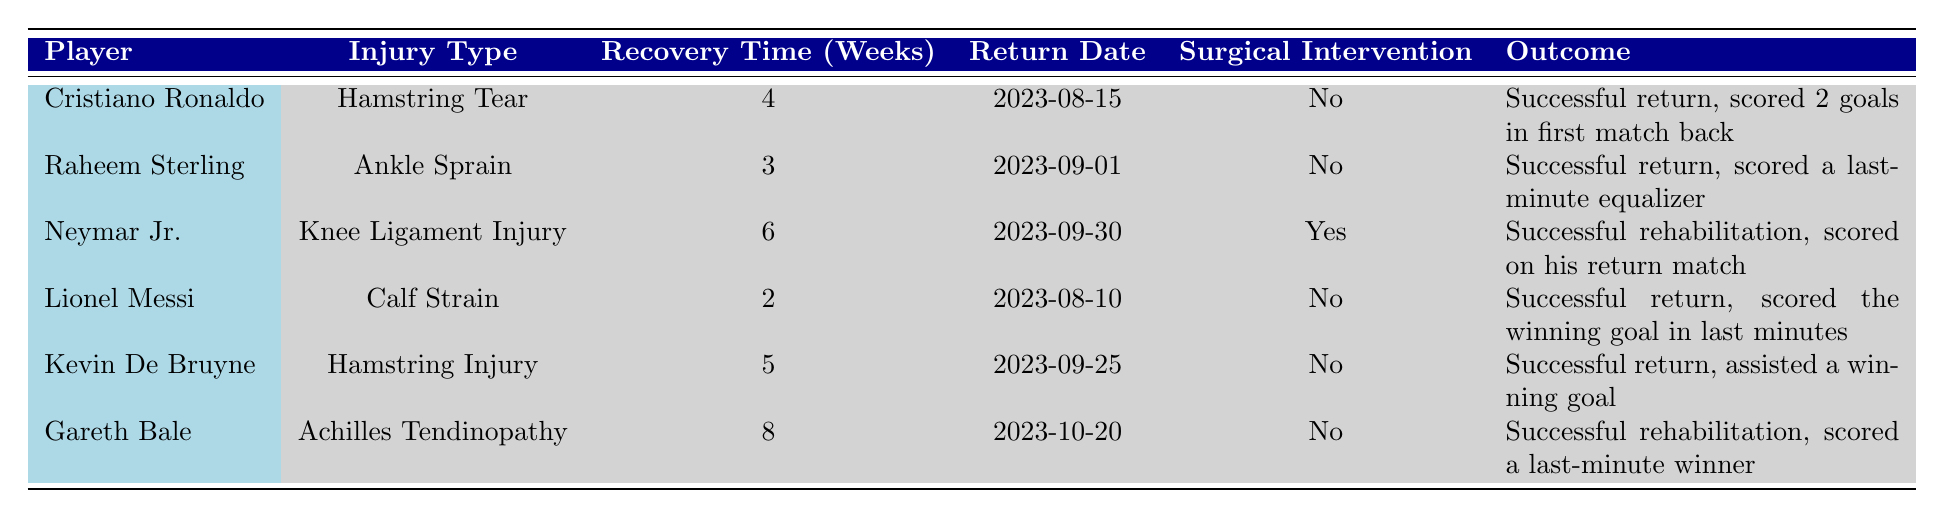What is the recovery time for Cristiano Ronaldo? The table lists the recovery time for Cristiano Ronaldo under the 'Recovery Time (Weeks)' column, which shows a value of 4 weeks.
Answer: 4 weeks Who returned from injury first among all players? By comparing the 'Return Date' for each player, Lionel Messi returned on 2023-08-10, which is earlier than the other players' return dates.
Answer: Lionel Messi Did Neymar Jr. undergo surgical intervention for his injury? The table indicates under the 'Surgical Intervention' column that Neymar Jr. had a "Yes" for surgical intervention.
Answer: Yes How many weeks of recovery did Raheem Sterling need compared to Kevin De Bruyne? Raheem Sterling's recovery time is 3 weeks and Kevin De Bruyne's is 5 weeks. The difference is 5 - 3 = 2 weeks.
Answer: 2 weeks Which players scored last-minute goals upon their return? By reviewing the 'Outcome' column, both Raheem Sterling (scored a last-minute equalizer) and Gareth Bale (scored a last-minute winner) achieved this.
Answer: Raheem Sterling and Gareth Bale What is the average recovery time for players who did not require surgical intervention? The players without surgical intervention are Cristiano Ronaldo (4 weeks), Raheem Sterling (3 weeks), Lionel Messi (2 weeks), Kevin De Bruyne (5 weeks), and Gareth Bale (8 weeks). The average is (4 + 3 + 2 + 5 + 8) / 5 = 22 / 5 = 4.4 weeks.
Answer: 4.4 weeks Who had the longest recovery time and what was it? By scanning the 'Recovery Time (Weeks)' column, Gareth Bale had the longest recovery time of 8 weeks.
Answer: 8 weeks What outcomes can be characterized as "successful rehabilitation"? The table indicates that Neymar Jr. and Gareth Bale had "Successful rehabilitation" noted in their outcomes.
Answer: Neymar Jr. and Gareth Bale 